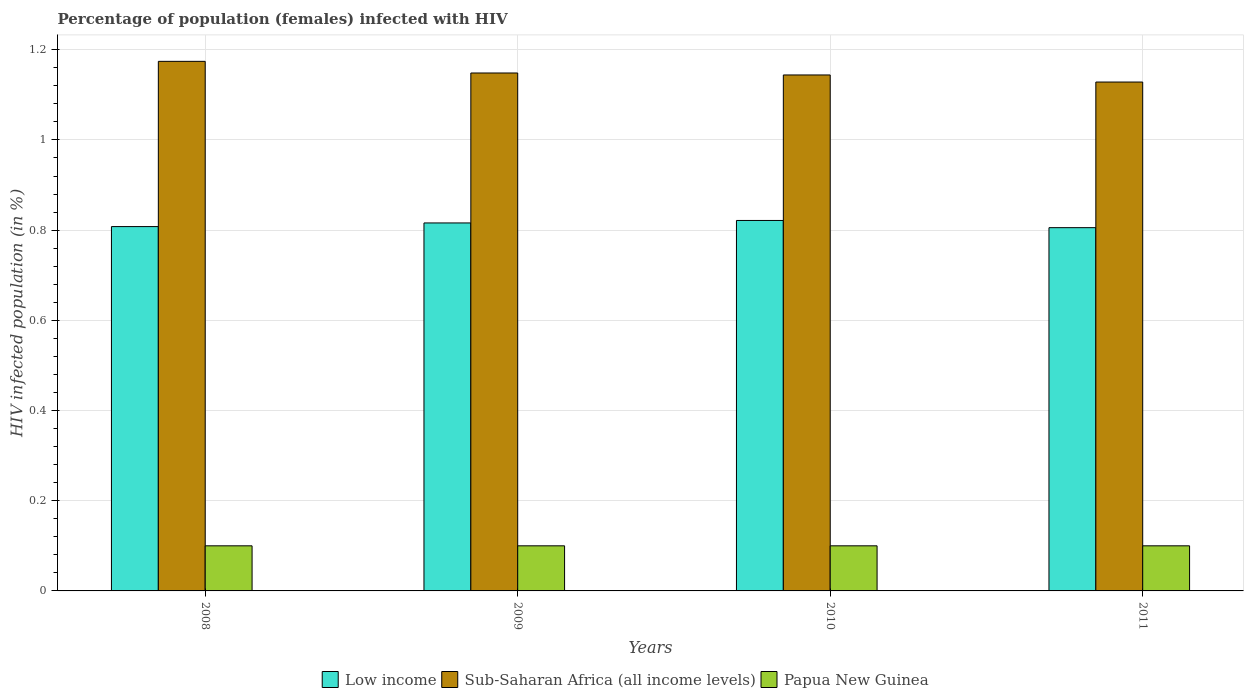Are the number of bars per tick equal to the number of legend labels?
Offer a terse response. Yes. Are the number of bars on each tick of the X-axis equal?
Keep it short and to the point. Yes. How many bars are there on the 1st tick from the right?
Provide a short and direct response. 3. In how many cases, is the number of bars for a given year not equal to the number of legend labels?
Give a very brief answer. 0. What is the percentage of HIV infected female population in Low income in 2010?
Ensure brevity in your answer.  0.82. Across all years, what is the maximum percentage of HIV infected female population in Sub-Saharan Africa (all income levels)?
Your response must be concise. 1.17. Across all years, what is the minimum percentage of HIV infected female population in Sub-Saharan Africa (all income levels)?
Keep it short and to the point. 1.13. In which year was the percentage of HIV infected female population in Low income maximum?
Ensure brevity in your answer.  2010. What is the total percentage of HIV infected female population in Low income in the graph?
Your response must be concise. 3.25. What is the difference between the percentage of HIV infected female population in Sub-Saharan Africa (all income levels) in 2008 and that in 2010?
Give a very brief answer. 0.03. What is the difference between the percentage of HIV infected female population in Low income in 2011 and the percentage of HIV infected female population in Sub-Saharan Africa (all income levels) in 2010?
Make the answer very short. -0.34. What is the average percentage of HIV infected female population in Sub-Saharan Africa (all income levels) per year?
Offer a very short reply. 1.15. In the year 2010, what is the difference between the percentage of HIV infected female population in Low income and percentage of HIV infected female population in Sub-Saharan Africa (all income levels)?
Offer a very short reply. -0.32. In how many years, is the percentage of HIV infected female population in Low income greater than 0.6400000000000001 %?
Make the answer very short. 4. Is the difference between the percentage of HIV infected female population in Low income in 2008 and 2010 greater than the difference between the percentage of HIV infected female population in Sub-Saharan Africa (all income levels) in 2008 and 2010?
Make the answer very short. No. What is the difference between the highest and the second highest percentage of HIV infected female population in Sub-Saharan Africa (all income levels)?
Provide a succinct answer. 0.03. What is the difference between the highest and the lowest percentage of HIV infected female population in Sub-Saharan Africa (all income levels)?
Keep it short and to the point. 0.05. In how many years, is the percentage of HIV infected female population in Low income greater than the average percentage of HIV infected female population in Low income taken over all years?
Offer a very short reply. 2. What does the 2nd bar from the left in 2011 represents?
Your response must be concise. Sub-Saharan Africa (all income levels). What does the 1st bar from the right in 2011 represents?
Offer a very short reply. Papua New Guinea. Is it the case that in every year, the sum of the percentage of HIV infected female population in Papua New Guinea and percentage of HIV infected female population in Low income is greater than the percentage of HIV infected female population in Sub-Saharan Africa (all income levels)?
Keep it short and to the point. No. How many bars are there?
Provide a short and direct response. 12. Are all the bars in the graph horizontal?
Your answer should be very brief. No. How many years are there in the graph?
Your answer should be compact. 4. What is the title of the graph?
Offer a very short reply. Percentage of population (females) infected with HIV. What is the label or title of the X-axis?
Make the answer very short. Years. What is the label or title of the Y-axis?
Your response must be concise. HIV infected population (in %). What is the HIV infected population (in %) in Low income in 2008?
Your answer should be very brief. 0.81. What is the HIV infected population (in %) of Sub-Saharan Africa (all income levels) in 2008?
Provide a short and direct response. 1.17. What is the HIV infected population (in %) in Low income in 2009?
Make the answer very short. 0.82. What is the HIV infected population (in %) in Sub-Saharan Africa (all income levels) in 2009?
Your response must be concise. 1.15. What is the HIV infected population (in %) in Low income in 2010?
Ensure brevity in your answer.  0.82. What is the HIV infected population (in %) of Sub-Saharan Africa (all income levels) in 2010?
Your answer should be very brief. 1.14. What is the HIV infected population (in %) in Papua New Guinea in 2010?
Offer a terse response. 0.1. What is the HIV infected population (in %) in Low income in 2011?
Give a very brief answer. 0.81. What is the HIV infected population (in %) in Sub-Saharan Africa (all income levels) in 2011?
Offer a terse response. 1.13. Across all years, what is the maximum HIV infected population (in %) in Low income?
Your answer should be very brief. 0.82. Across all years, what is the maximum HIV infected population (in %) in Sub-Saharan Africa (all income levels)?
Your answer should be very brief. 1.17. Across all years, what is the minimum HIV infected population (in %) in Low income?
Your answer should be compact. 0.81. Across all years, what is the minimum HIV infected population (in %) of Sub-Saharan Africa (all income levels)?
Your response must be concise. 1.13. Across all years, what is the minimum HIV infected population (in %) in Papua New Guinea?
Your answer should be compact. 0.1. What is the total HIV infected population (in %) of Low income in the graph?
Give a very brief answer. 3.25. What is the total HIV infected population (in %) in Sub-Saharan Africa (all income levels) in the graph?
Give a very brief answer. 4.6. What is the difference between the HIV infected population (in %) of Low income in 2008 and that in 2009?
Provide a short and direct response. -0.01. What is the difference between the HIV infected population (in %) in Sub-Saharan Africa (all income levels) in 2008 and that in 2009?
Make the answer very short. 0.03. What is the difference between the HIV infected population (in %) in Low income in 2008 and that in 2010?
Your answer should be compact. -0.01. What is the difference between the HIV infected population (in %) in Sub-Saharan Africa (all income levels) in 2008 and that in 2010?
Your response must be concise. 0.03. What is the difference between the HIV infected population (in %) of Low income in 2008 and that in 2011?
Your answer should be compact. 0. What is the difference between the HIV infected population (in %) of Sub-Saharan Africa (all income levels) in 2008 and that in 2011?
Your answer should be compact. 0.05. What is the difference between the HIV infected population (in %) in Papua New Guinea in 2008 and that in 2011?
Provide a succinct answer. 0. What is the difference between the HIV infected population (in %) in Low income in 2009 and that in 2010?
Make the answer very short. -0.01. What is the difference between the HIV infected population (in %) of Sub-Saharan Africa (all income levels) in 2009 and that in 2010?
Provide a short and direct response. 0. What is the difference between the HIV infected population (in %) of Papua New Guinea in 2009 and that in 2010?
Provide a succinct answer. 0. What is the difference between the HIV infected population (in %) in Low income in 2009 and that in 2011?
Give a very brief answer. 0.01. What is the difference between the HIV infected population (in %) of Sub-Saharan Africa (all income levels) in 2009 and that in 2011?
Make the answer very short. 0.02. What is the difference between the HIV infected population (in %) in Low income in 2010 and that in 2011?
Keep it short and to the point. 0.02. What is the difference between the HIV infected population (in %) in Sub-Saharan Africa (all income levels) in 2010 and that in 2011?
Give a very brief answer. 0.02. What is the difference between the HIV infected population (in %) in Papua New Guinea in 2010 and that in 2011?
Your answer should be compact. 0. What is the difference between the HIV infected population (in %) in Low income in 2008 and the HIV infected population (in %) in Sub-Saharan Africa (all income levels) in 2009?
Provide a succinct answer. -0.34. What is the difference between the HIV infected population (in %) of Low income in 2008 and the HIV infected population (in %) of Papua New Guinea in 2009?
Your answer should be very brief. 0.71. What is the difference between the HIV infected population (in %) in Sub-Saharan Africa (all income levels) in 2008 and the HIV infected population (in %) in Papua New Guinea in 2009?
Provide a succinct answer. 1.07. What is the difference between the HIV infected population (in %) in Low income in 2008 and the HIV infected population (in %) in Sub-Saharan Africa (all income levels) in 2010?
Keep it short and to the point. -0.34. What is the difference between the HIV infected population (in %) in Low income in 2008 and the HIV infected population (in %) in Papua New Guinea in 2010?
Your answer should be very brief. 0.71. What is the difference between the HIV infected population (in %) in Sub-Saharan Africa (all income levels) in 2008 and the HIV infected population (in %) in Papua New Guinea in 2010?
Provide a short and direct response. 1.07. What is the difference between the HIV infected population (in %) in Low income in 2008 and the HIV infected population (in %) in Sub-Saharan Africa (all income levels) in 2011?
Ensure brevity in your answer.  -0.32. What is the difference between the HIV infected population (in %) in Low income in 2008 and the HIV infected population (in %) in Papua New Guinea in 2011?
Provide a succinct answer. 0.71. What is the difference between the HIV infected population (in %) in Sub-Saharan Africa (all income levels) in 2008 and the HIV infected population (in %) in Papua New Guinea in 2011?
Ensure brevity in your answer.  1.07. What is the difference between the HIV infected population (in %) in Low income in 2009 and the HIV infected population (in %) in Sub-Saharan Africa (all income levels) in 2010?
Ensure brevity in your answer.  -0.33. What is the difference between the HIV infected population (in %) in Low income in 2009 and the HIV infected population (in %) in Papua New Guinea in 2010?
Make the answer very short. 0.72. What is the difference between the HIV infected population (in %) of Sub-Saharan Africa (all income levels) in 2009 and the HIV infected population (in %) of Papua New Guinea in 2010?
Ensure brevity in your answer.  1.05. What is the difference between the HIV infected population (in %) in Low income in 2009 and the HIV infected population (in %) in Sub-Saharan Africa (all income levels) in 2011?
Your answer should be very brief. -0.31. What is the difference between the HIV infected population (in %) of Low income in 2009 and the HIV infected population (in %) of Papua New Guinea in 2011?
Ensure brevity in your answer.  0.72. What is the difference between the HIV infected population (in %) of Sub-Saharan Africa (all income levels) in 2009 and the HIV infected population (in %) of Papua New Guinea in 2011?
Your answer should be very brief. 1.05. What is the difference between the HIV infected population (in %) of Low income in 2010 and the HIV infected population (in %) of Sub-Saharan Africa (all income levels) in 2011?
Give a very brief answer. -0.31. What is the difference between the HIV infected population (in %) of Low income in 2010 and the HIV infected population (in %) of Papua New Guinea in 2011?
Your answer should be very brief. 0.72. What is the difference between the HIV infected population (in %) in Sub-Saharan Africa (all income levels) in 2010 and the HIV infected population (in %) in Papua New Guinea in 2011?
Give a very brief answer. 1.04. What is the average HIV infected population (in %) in Low income per year?
Provide a short and direct response. 0.81. What is the average HIV infected population (in %) of Sub-Saharan Africa (all income levels) per year?
Give a very brief answer. 1.15. What is the average HIV infected population (in %) of Papua New Guinea per year?
Offer a terse response. 0.1. In the year 2008, what is the difference between the HIV infected population (in %) of Low income and HIV infected population (in %) of Sub-Saharan Africa (all income levels)?
Make the answer very short. -0.37. In the year 2008, what is the difference between the HIV infected population (in %) of Low income and HIV infected population (in %) of Papua New Guinea?
Provide a short and direct response. 0.71. In the year 2008, what is the difference between the HIV infected population (in %) of Sub-Saharan Africa (all income levels) and HIV infected population (in %) of Papua New Guinea?
Your answer should be very brief. 1.07. In the year 2009, what is the difference between the HIV infected population (in %) in Low income and HIV infected population (in %) in Sub-Saharan Africa (all income levels)?
Provide a succinct answer. -0.33. In the year 2009, what is the difference between the HIV infected population (in %) in Low income and HIV infected population (in %) in Papua New Guinea?
Your response must be concise. 0.72. In the year 2009, what is the difference between the HIV infected population (in %) in Sub-Saharan Africa (all income levels) and HIV infected population (in %) in Papua New Guinea?
Ensure brevity in your answer.  1.05. In the year 2010, what is the difference between the HIV infected population (in %) of Low income and HIV infected population (in %) of Sub-Saharan Africa (all income levels)?
Provide a succinct answer. -0.32. In the year 2010, what is the difference between the HIV infected population (in %) of Low income and HIV infected population (in %) of Papua New Guinea?
Make the answer very short. 0.72. In the year 2010, what is the difference between the HIV infected population (in %) of Sub-Saharan Africa (all income levels) and HIV infected population (in %) of Papua New Guinea?
Provide a succinct answer. 1.04. In the year 2011, what is the difference between the HIV infected population (in %) of Low income and HIV infected population (in %) of Sub-Saharan Africa (all income levels)?
Give a very brief answer. -0.32. In the year 2011, what is the difference between the HIV infected population (in %) of Low income and HIV infected population (in %) of Papua New Guinea?
Your answer should be very brief. 0.71. In the year 2011, what is the difference between the HIV infected population (in %) of Sub-Saharan Africa (all income levels) and HIV infected population (in %) of Papua New Guinea?
Provide a short and direct response. 1.03. What is the ratio of the HIV infected population (in %) in Sub-Saharan Africa (all income levels) in 2008 to that in 2009?
Keep it short and to the point. 1.02. What is the ratio of the HIV infected population (in %) of Papua New Guinea in 2008 to that in 2009?
Your answer should be compact. 1. What is the ratio of the HIV infected population (in %) of Low income in 2008 to that in 2010?
Provide a succinct answer. 0.98. What is the ratio of the HIV infected population (in %) in Sub-Saharan Africa (all income levels) in 2008 to that in 2010?
Give a very brief answer. 1.03. What is the ratio of the HIV infected population (in %) of Sub-Saharan Africa (all income levels) in 2008 to that in 2011?
Provide a short and direct response. 1.04. What is the ratio of the HIV infected population (in %) in Papua New Guinea in 2008 to that in 2011?
Offer a terse response. 1. What is the ratio of the HIV infected population (in %) in Low income in 2009 to that in 2010?
Keep it short and to the point. 0.99. What is the ratio of the HIV infected population (in %) of Papua New Guinea in 2009 to that in 2010?
Offer a terse response. 1. What is the ratio of the HIV infected population (in %) in Sub-Saharan Africa (all income levels) in 2009 to that in 2011?
Your response must be concise. 1.02. What is the ratio of the HIV infected population (in %) of Low income in 2010 to that in 2011?
Provide a succinct answer. 1.02. What is the ratio of the HIV infected population (in %) in Sub-Saharan Africa (all income levels) in 2010 to that in 2011?
Your response must be concise. 1.01. What is the difference between the highest and the second highest HIV infected population (in %) in Low income?
Provide a short and direct response. 0.01. What is the difference between the highest and the second highest HIV infected population (in %) in Sub-Saharan Africa (all income levels)?
Offer a terse response. 0.03. What is the difference between the highest and the second highest HIV infected population (in %) of Papua New Guinea?
Make the answer very short. 0. What is the difference between the highest and the lowest HIV infected population (in %) of Low income?
Offer a very short reply. 0.02. What is the difference between the highest and the lowest HIV infected population (in %) in Sub-Saharan Africa (all income levels)?
Your response must be concise. 0.05. 